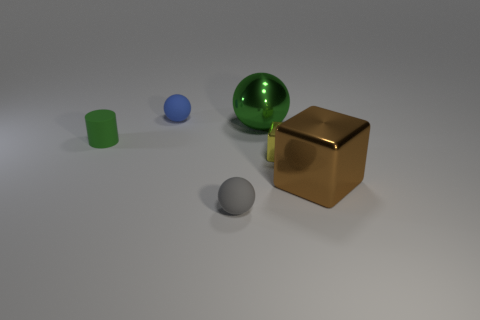Is there anything else that has the same shape as the small green matte object?
Keep it short and to the point. No. What is the color of the shiny block that is the same size as the rubber cylinder?
Provide a short and direct response. Yellow. Do the big metallic object that is to the left of the big brown metallic cube and the matte cylinder have the same color?
Ensure brevity in your answer.  Yes. Are there any green objects that have the same material as the small gray thing?
Provide a succinct answer. Yes. There is a tiny rubber object that is the same color as the large sphere; what is its shape?
Offer a terse response. Cylinder. Are there fewer rubber balls that are behind the big green thing than rubber things?
Provide a short and direct response. Yes. Do the green metal ball that is on the right side of the blue object and the blue thing have the same size?
Offer a terse response. No. What number of other blue matte objects are the same shape as the tiny blue matte thing?
Offer a very short reply. 0. What size is the green ball that is made of the same material as the brown block?
Give a very brief answer. Large. Is the number of green metallic spheres that are behind the small blue matte object the same as the number of tiny gray blocks?
Provide a short and direct response. Yes. 